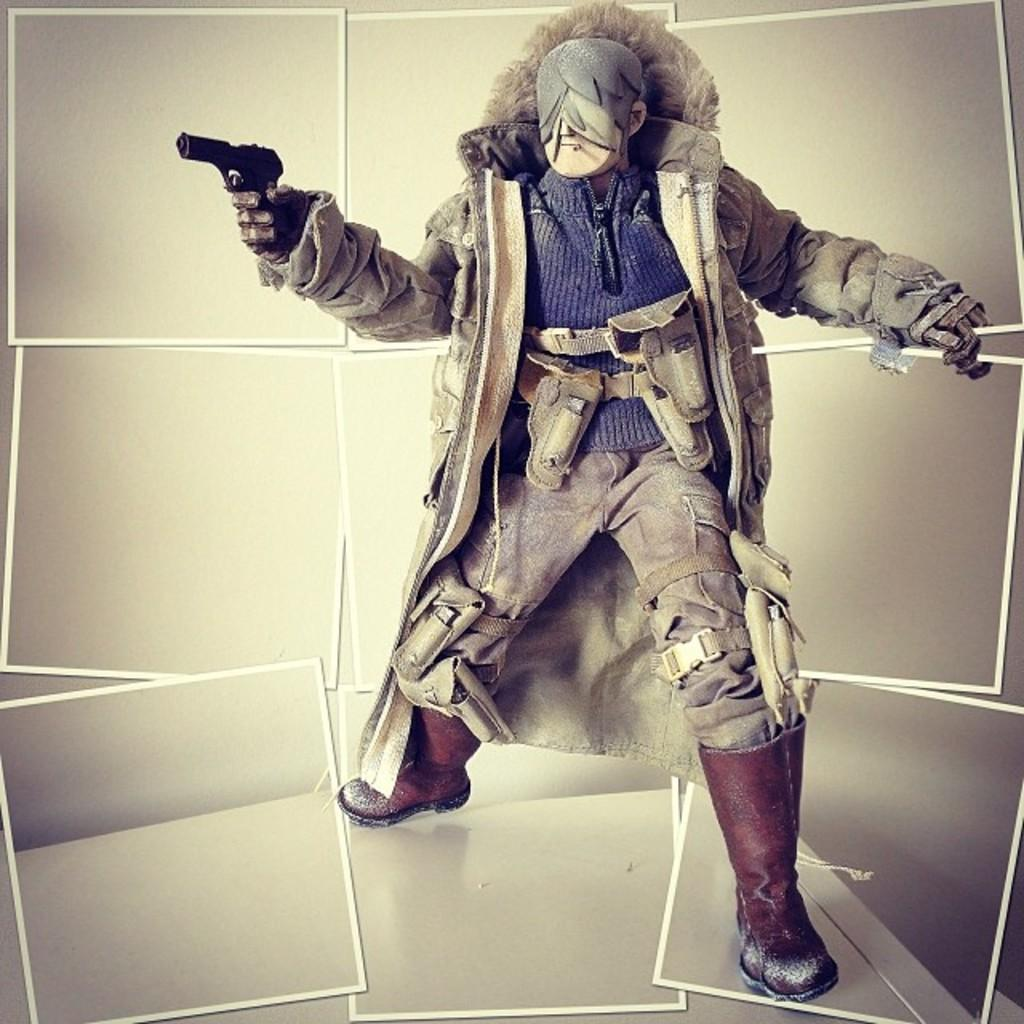Who is present in the image? There is a man in the image. What is the man holding in the image? The man is holding a gun in the image. Is the man taking a bath in the image? No, the man is not taking a bath in the image. 